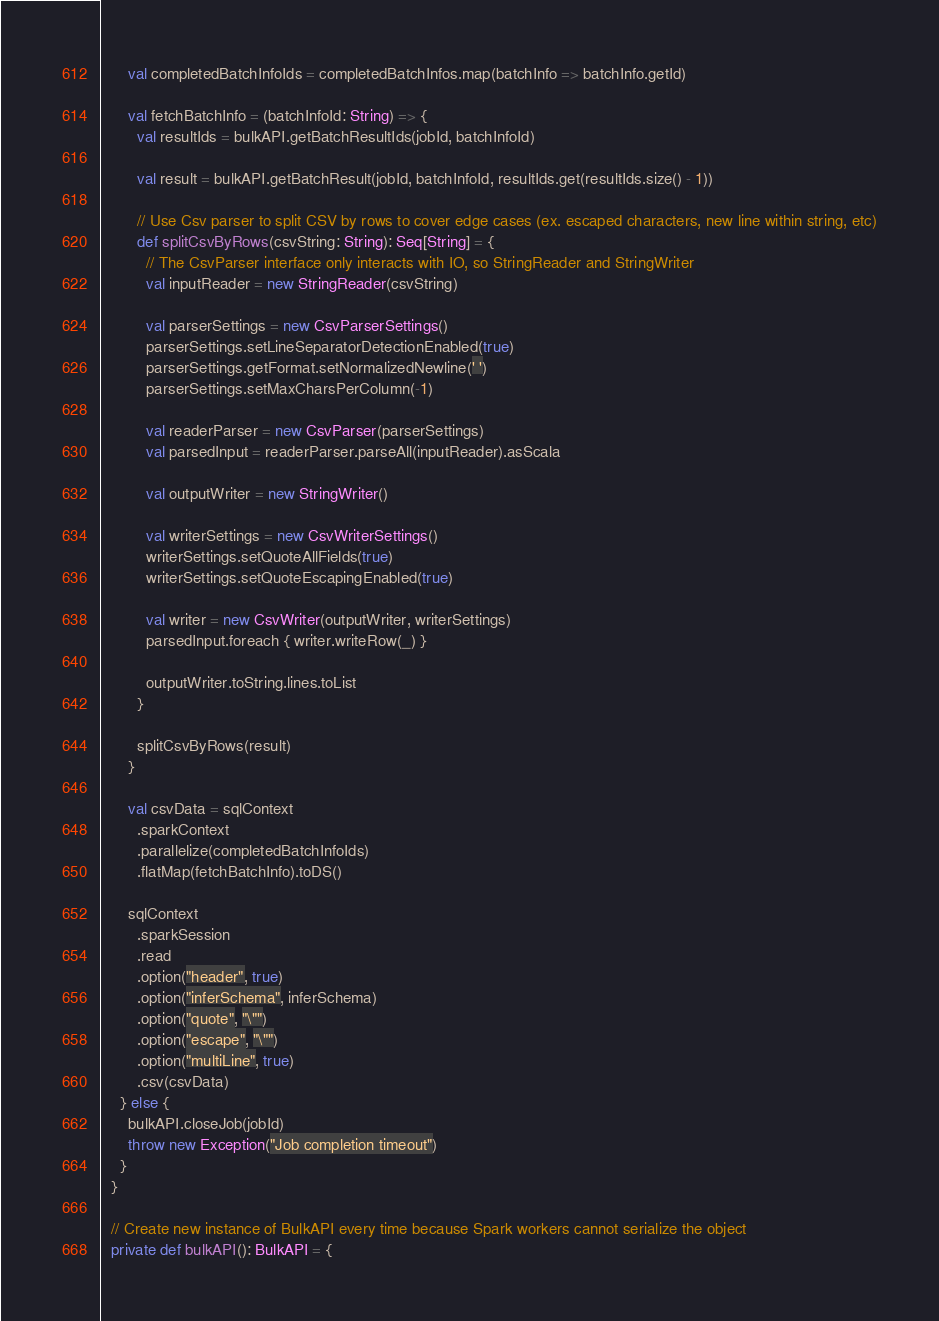Convert code to text. <code><loc_0><loc_0><loc_500><loc_500><_Scala_>      val completedBatchInfoIds = completedBatchInfos.map(batchInfo => batchInfo.getId)

      val fetchBatchInfo = (batchInfoId: String) => {
        val resultIds = bulkAPI.getBatchResultIds(jobId, batchInfoId)

        val result = bulkAPI.getBatchResult(jobId, batchInfoId, resultIds.get(resultIds.size() - 1))

        // Use Csv parser to split CSV by rows to cover edge cases (ex. escaped characters, new line within string, etc)
        def splitCsvByRows(csvString: String): Seq[String] = {
          // The CsvParser interface only interacts with IO, so StringReader and StringWriter
          val inputReader = new StringReader(csvString)

          val parserSettings = new CsvParserSettings()
          parserSettings.setLineSeparatorDetectionEnabled(true)
          parserSettings.getFormat.setNormalizedNewline(' ')
          parserSettings.setMaxCharsPerColumn(-1)

          val readerParser = new CsvParser(parserSettings)
          val parsedInput = readerParser.parseAll(inputReader).asScala

          val outputWriter = new StringWriter()

          val writerSettings = new CsvWriterSettings()
          writerSettings.setQuoteAllFields(true)
          writerSettings.setQuoteEscapingEnabled(true)

          val writer = new CsvWriter(outputWriter, writerSettings)
          parsedInput.foreach { writer.writeRow(_) }

          outputWriter.toString.lines.toList
        }

        splitCsvByRows(result)
      }

      val csvData = sqlContext
        .sparkContext
        .parallelize(completedBatchInfoIds)
        .flatMap(fetchBatchInfo).toDS()

      sqlContext
        .sparkSession
        .read
        .option("header", true)
        .option("inferSchema", inferSchema)
        .option("quote", "\"")
        .option("escape", "\"")
        .option("multiLine", true)
        .csv(csvData)
    } else {
      bulkAPI.closeJob(jobId)
      throw new Exception("Job completion timeout")
    }
  }

  // Create new instance of BulkAPI every time because Spark workers cannot serialize the object
  private def bulkAPI(): BulkAPI = {</code> 